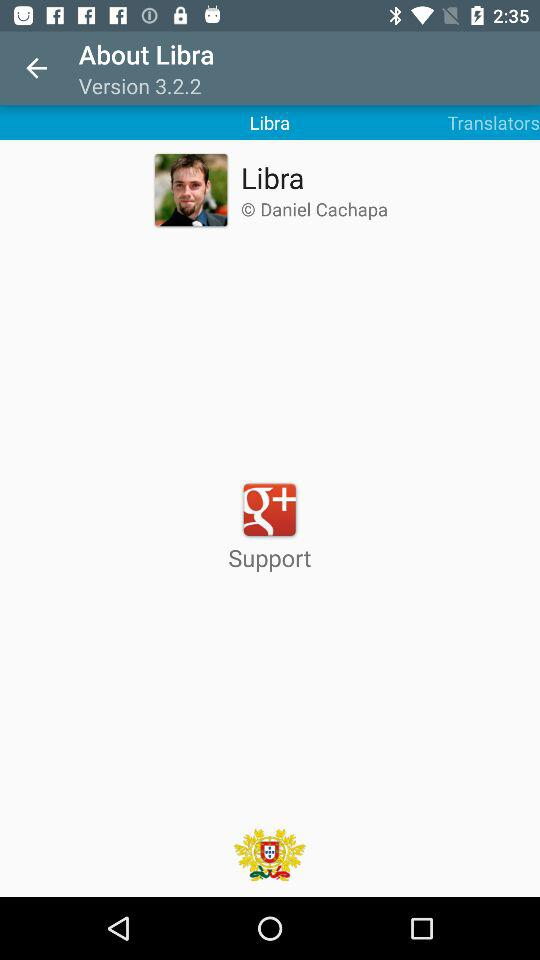How do I contact support?
When the provided information is insufficient, respond with <no answer>. <no answer> 